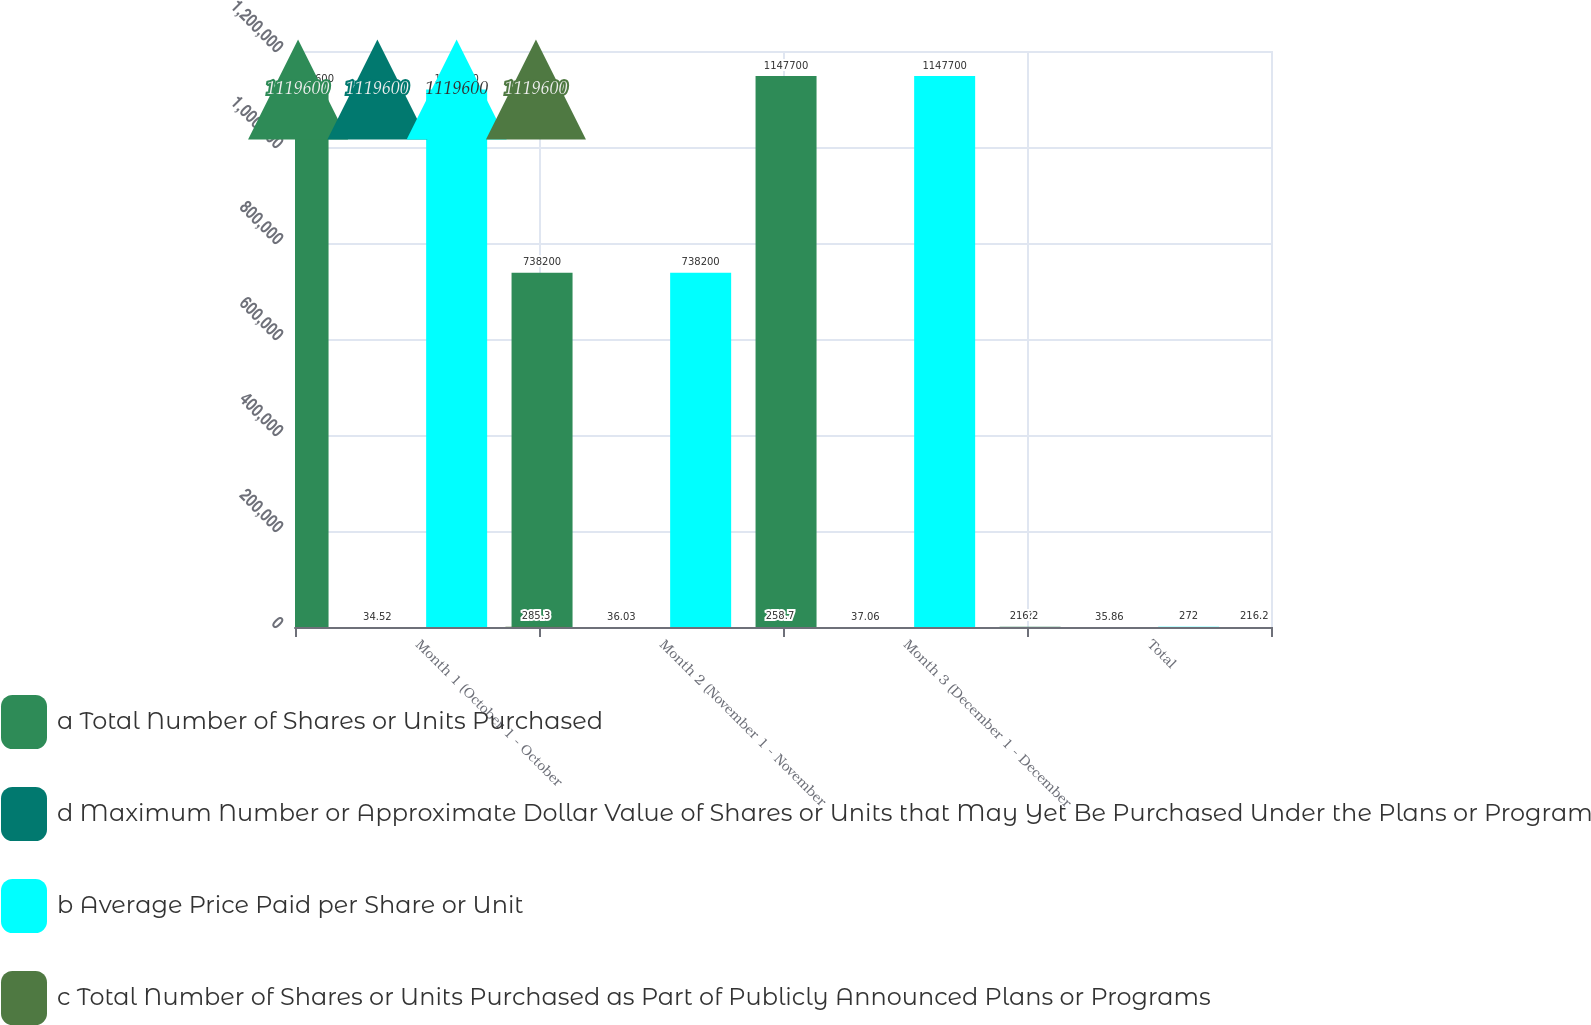Convert chart to OTSL. <chart><loc_0><loc_0><loc_500><loc_500><stacked_bar_chart><ecel><fcel>Month 1 (October 1 - October<fcel>Month 2 (November 1 - November<fcel>Month 3 (December 1 - December<fcel>Total<nl><fcel>a Total Number of Shares or Units Purchased<fcel>1.1196e+06<fcel>738200<fcel>1.1477e+06<fcel>272<nl><fcel>d Maximum Number or Approximate Dollar Value of Shares or Units that May Yet Be Purchased Under the Plans or Programs in millions<fcel>34.52<fcel>36.03<fcel>37.06<fcel>35.86<nl><fcel>b Average Price Paid per Share or Unit<fcel>1.1196e+06<fcel>738200<fcel>1.1477e+06<fcel>272<nl><fcel>c Total Number of Shares or Units Purchased as Part of Publicly Announced Plans or Programs<fcel>285.3<fcel>258.7<fcel>216.2<fcel>216.2<nl></chart> 